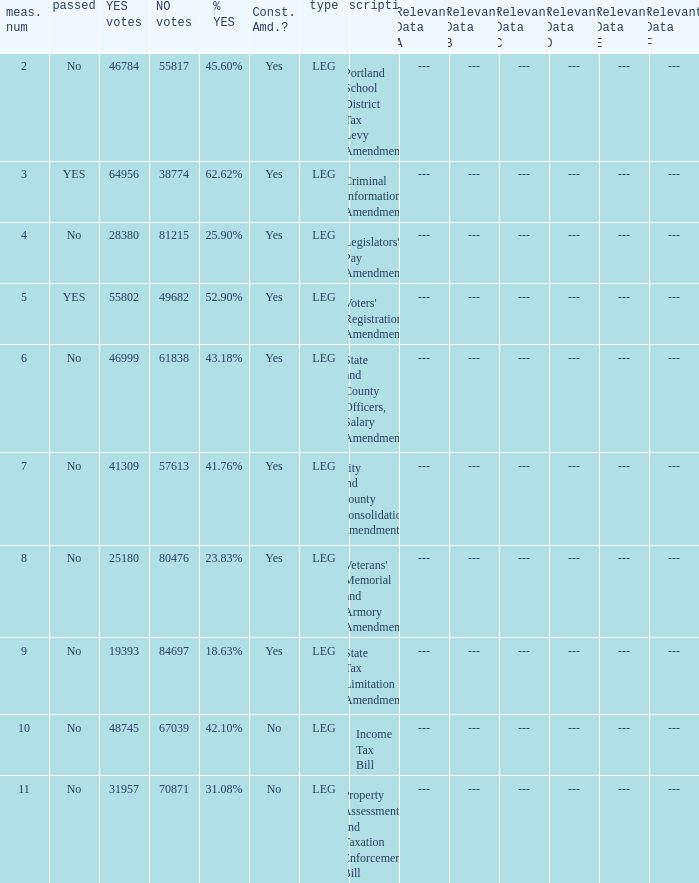HOw many no votes were there when there were 45.60% yes votes 55817.0. 